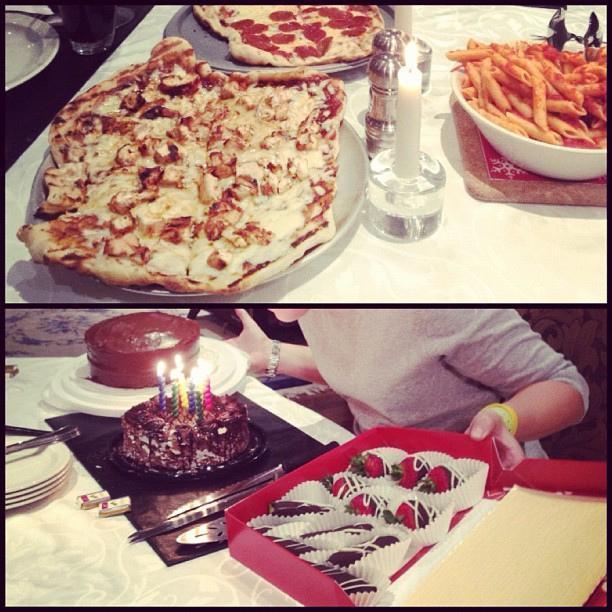How many dining tables can you see?
Give a very brief answer. 2. How many pizzas are visible?
Give a very brief answer. 2. How many cakes are there?
Give a very brief answer. 2. How many bowls can you see?
Give a very brief answer. 2. 